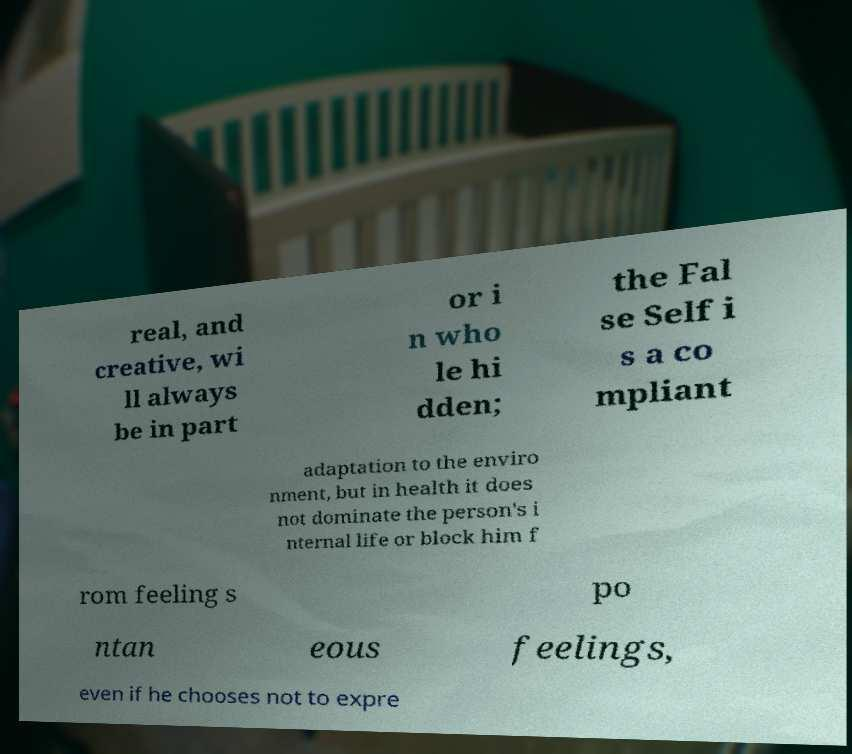There's text embedded in this image that I need extracted. Can you transcribe it verbatim? real, and creative, wi ll always be in part or i n who le hi dden; the Fal se Self i s a co mpliant adaptation to the enviro nment, but in health it does not dominate the person's i nternal life or block him f rom feeling s po ntan eous feelings, even if he chooses not to expre 